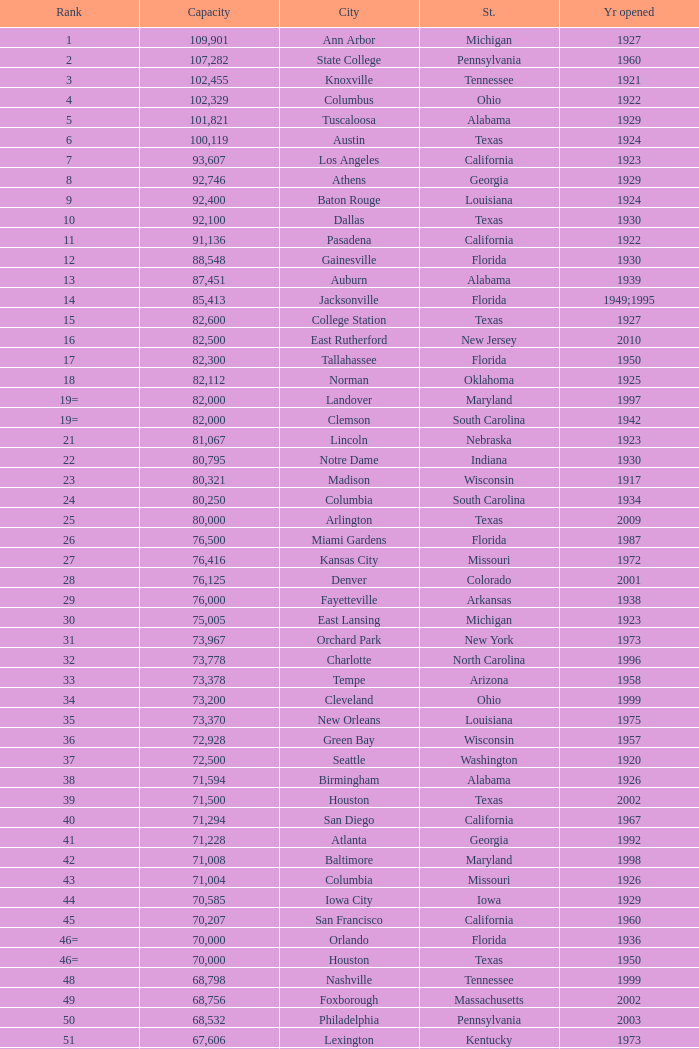What is the city in Alabama that opened in 1996? Huntsville. 